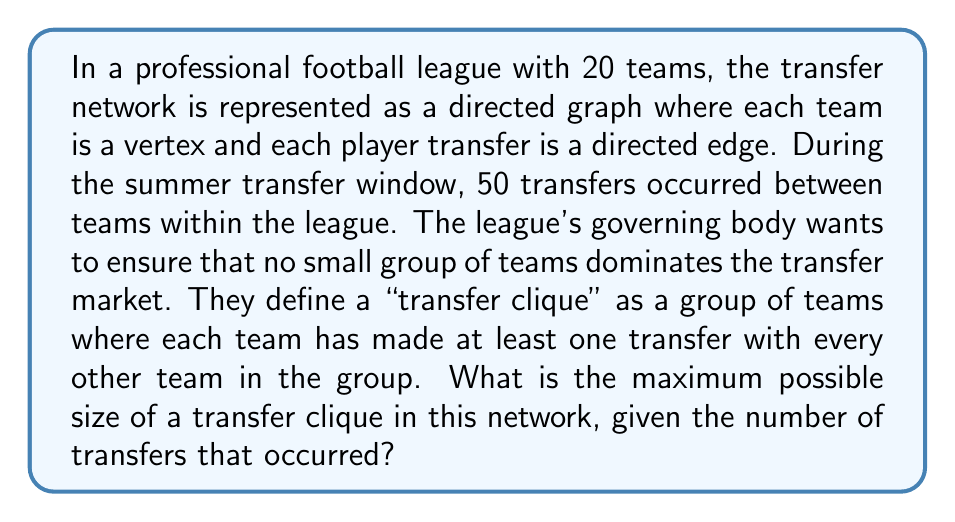Show me your answer to this math problem. To solve this problem, we need to use concepts from graph theory, specifically the relationship between the number of edges and the maximum possible clique size in a graph.

1) First, let's consider what a transfer clique represents in this context. It's a complete subgraph where every team has made a transfer with every other team in the clique.

2) In a complete graph with $n$ vertices, the number of edges is $\frac{n(n-1)}{2}$.

3) We're looking for the largest possible $n$ such that $\frac{n(n-1)}{2} \leq 50$, as 50 is the total number of transfers.

4) This inequality can be rewritten as:

   $$n^2 - n - 100 \leq 0$$

5) We can solve this quadratic inequality:

   $$n = \frac{1 \pm \sqrt{1 + 4(100)}}{2} = \frac{1 \pm \sqrt{401}}{2}$$

6) Since $n$ must be positive, we take the positive root:

   $$n \leq \frac{1 + \sqrt{401}}{2} \approx 10.52$$

7) Since $n$ must be an integer, the largest possible value for $n$ is 10.

8) We can verify: $\frac{10(9)}{2} = 45 < 50$, but $\frac{11(10)}{2} = 55 > 50$

This solution aligns with the persona of a football enthusiast concerned about nepotism, as it shows how the league is monitoring the transfer market to prevent a small group of teams from dominating transfers.
Answer: The maximum possible size of a transfer clique in this network is 10 teams. 